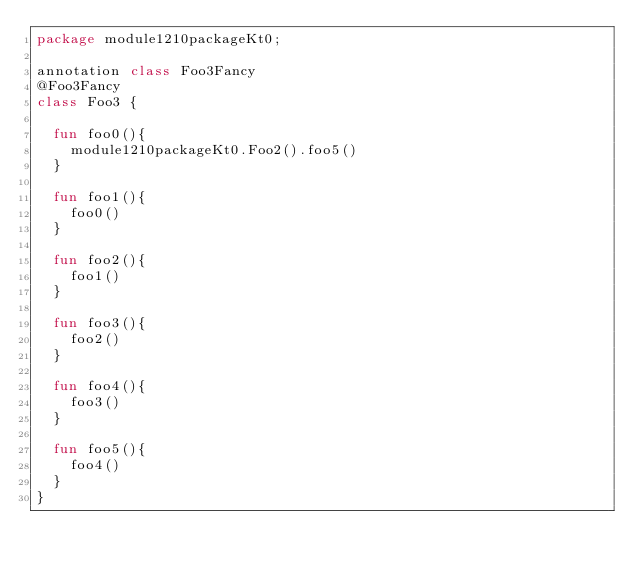<code> <loc_0><loc_0><loc_500><loc_500><_Kotlin_>package module1210packageKt0;

annotation class Foo3Fancy
@Foo3Fancy
class Foo3 {

  fun foo0(){
    module1210packageKt0.Foo2().foo5()
  }

  fun foo1(){
    foo0()
  }

  fun foo2(){
    foo1()
  }

  fun foo3(){
    foo2()
  }

  fun foo4(){
    foo3()
  }

  fun foo5(){
    foo4()
  }
}</code> 